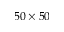Convert formula to latex. <formula><loc_0><loc_0><loc_500><loc_500>5 0 \times 5 0</formula> 